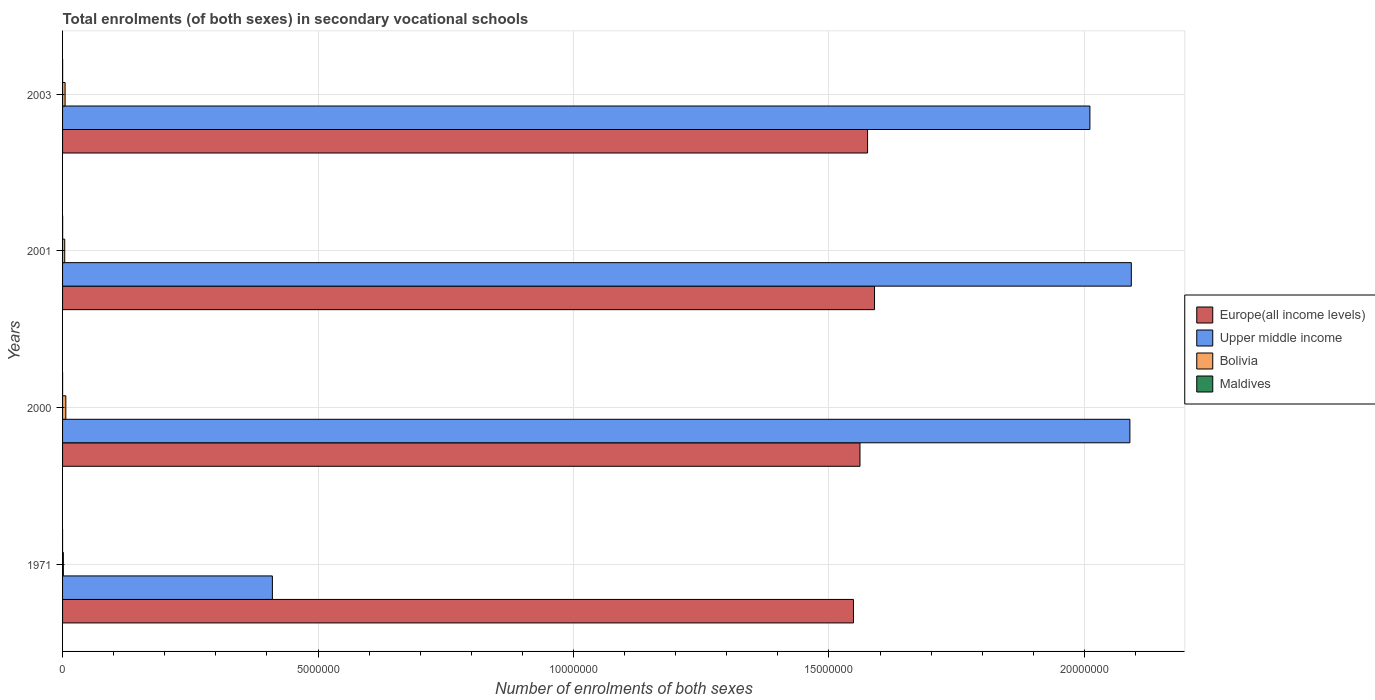How many different coloured bars are there?
Offer a very short reply. 4. Are the number of bars on each tick of the Y-axis equal?
Provide a short and direct response. Yes. How many bars are there on the 2nd tick from the top?
Provide a succinct answer. 4. How many bars are there on the 1st tick from the bottom?
Offer a terse response. 4. What is the label of the 1st group of bars from the top?
Your response must be concise. 2003. What is the number of enrolments in secondary schools in Bolivia in 2000?
Give a very brief answer. 6.38e+04. Across all years, what is the maximum number of enrolments in secondary schools in Upper middle income?
Your answer should be very brief. 2.09e+07. Across all years, what is the minimum number of enrolments in secondary schools in Europe(all income levels)?
Offer a very short reply. 1.55e+07. In which year was the number of enrolments in secondary schools in Maldives minimum?
Make the answer very short. 1971. What is the total number of enrolments in secondary schools in Maldives in the graph?
Your answer should be compact. 3080. What is the difference between the number of enrolments in secondary schools in Bolivia in 1971 and that in 2003?
Provide a short and direct response. -3.39e+04. What is the difference between the number of enrolments in secondary schools in Europe(all income levels) in 1971 and the number of enrolments in secondary schools in Maldives in 2003?
Your answer should be compact. 1.55e+07. What is the average number of enrolments in secondary schools in Europe(all income levels) per year?
Give a very brief answer. 1.57e+07. In the year 2000, what is the difference between the number of enrolments in secondary schools in Maldives and number of enrolments in secondary schools in Europe(all income levels)?
Your answer should be very brief. -1.56e+07. What is the ratio of the number of enrolments in secondary schools in Europe(all income levels) in 2001 to that in 2003?
Provide a short and direct response. 1.01. Is the number of enrolments in secondary schools in Maldives in 1971 less than that in 2000?
Your answer should be very brief. Yes. What is the difference between the highest and the second highest number of enrolments in secondary schools in Bolivia?
Provide a short and direct response. 1.42e+04. What is the difference between the highest and the lowest number of enrolments in secondary schools in Bolivia?
Provide a short and direct response. 4.81e+04. What does the 3rd bar from the top in 1971 represents?
Your answer should be compact. Upper middle income. What does the 1st bar from the bottom in 2001 represents?
Your response must be concise. Europe(all income levels). Is it the case that in every year, the sum of the number of enrolments in secondary schools in Maldives and number of enrolments in secondary schools in Bolivia is greater than the number of enrolments in secondary schools in Europe(all income levels)?
Provide a succinct answer. No. How many bars are there?
Your answer should be very brief. 16. What is the difference between two consecutive major ticks on the X-axis?
Offer a very short reply. 5.00e+06. Does the graph contain grids?
Offer a terse response. Yes. Where does the legend appear in the graph?
Your answer should be very brief. Center right. How many legend labels are there?
Offer a terse response. 4. What is the title of the graph?
Your answer should be compact. Total enrolments (of both sexes) in secondary vocational schools. Does "Mauritius" appear as one of the legend labels in the graph?
Your response must be concise. No. What is the label or title of the X-axis?
Give a very brief answer. Number of enrolments of both sexes. What is the Number of enrolments of both sexes in Europe(all income levels) in 1971?
Offer a very short reply. 1.55e+07. What is the Number of enrolments of both sexes of Upper middle income in 1971?
Your answer should be compact. 4.11e+06. What is the Number of enrolments of both sexes in Bolivia in 1971?
Provide a short and direct response. 1.57e+04. What is the Number of enrolments of both sexes in Maldives in 1971?
Offer a very short reply. 11. What is the Number of enrolments of both sexes in Europe(all income levels) in 2000?
Your answer should be very brief. 1.56e+07. What is the Number of enrolments of both sexes of Upper middle income in 2000?
Keep it short and to the point. 2.09e+07. What is the Number of enrolments of both sexes of Bolivia in 2000?
Your answer should be very brief. 6.38e+04. What is the Number of enrolments of both sexes of Maldives in 2000?
Provide a succinct answer. 457. What is the Number of enrolments of both sexes of Europe(all income levels) in 2001?
Your answer should be compact. 1.59e+07. What is the Number of enrolments of both sexes in Upper middle income in 2001?
Provide a succinct answer. 2.09e+07. What is the Number of enrolments of both sexes in Bolivia in 2001?
Ensure brevity in your answer.  4.20e+04. What is the Number of enrolments of both sexes in Maldives in 2001?
Make the answer very short. 1521. What is the Number of enrolments of both sexes in Europe(all income levels) in 2003?
Your response must be concise. 1.58e+07. What is the Number of enrolments of both sexes of Upper middle income in 2003?
Your response must be concise. 2.01e+07. What is the Number of enrolments of both sexes of Bolivia in 2003?
Provide a short and direct response. 4.96e+04. What is the Number of enrolments of both sexes of Maldives in 2003?
Your answer should be compact. 1091. Across all years, what is the maximum Number of enrolments of both sexes of Europe(all income levels)?
Your answer should be compact. 1.59e+07. Across all years, what is the maximum Number of enrolments of both sexes of Upper middle income?
Provide a short and direct response. 2.09e+07. Across all years, what is the maximum Number of enrolments of both sexes in Bolivia?
Your answer should be compact. 6.38e+04. Across all years, what is the maximum Number of enrolments of both sexes in Maldives?
Make the answer very short. 1521. Across all years, what is the minimum Number of enrolments of both sexes in Europe(all income levels)?
Offer a terse response. 1.55e+07. Across all years, what is the minimum Number of enrolments of both sexes in Upper middle income?
Give a very brief answer. 4.11e+06. Across all years, what is the minimum Number of enrolments of both sexes in Bolivia?
Provide a short and direct response. 1.57e+04. What is the total Number of enrolments of both sexes of Europe(all income levels) in the graph?
Your response must be concise. 6.27e+07. What is the total Number of enrolments of both sexes in Upper middle income in the graph?
Provide a succinct answer. 6.60e+07. What is the total Number of enrolments of both sexes of Bolivia in the graph?
Make the answer very short. 1.71e+05. What is the total Number of enrolments of both sexes in Maldives in the graph?
Your answer should be very brief. 3080. What is the difference between the Number of enrolments of both sexes of Europe(all income levels) in 1971 and that in 2000?
Provide a succinct answer. -1.27e+05. What is the difference between the Number of enrolments of both sexes in Upper middle income in 1971 and that in 2000?
Offer a very short reply. -1.68e+07. What is the difference between the Number of enrolments of both sexes of Bolivia in 1971 and that in 2000?
Make the answer very short. -4.81e+04. What is the difference between the Number of enrolments of both sexes of Maldives in 1971 and that in 2000?
Your response must be concise. -446. What is the difference between the Number of enrolments of both sexes of Europe(all income levels) in 1971 and that in 2001?
Offer a very short reply. -4.12e+05. What is the difference between the Number of enrolments of both sexes of Upper middle income in 1971 and that in 2001?
Provide a short and direct response. -1.68e+07. What is the difference between the Number of enrolments of both sexes in Bolivia in 1971 and that in 2001?
Your response must be concise. -2.63e+04. What is the difference between the Number of enrolments of both sexes of Maldives in 1971 and that in 2001?
Keep it short and to the point. -1510. What is the difference between the Number of enrolments of both sexes of Europe(all income levels) in 1971 and that in 2003?
Keep it short and to the point. -2.76e+05. What is the difference between the Number of enrolments of both sexes in Upper middle income in 1971 and that in 2003?
Keep it short and to the point. -1.60e+07. What is the difference between the Number of enrolments of both sexes of Bolivia in 1971 and that in 2003?
Give a very brief answer. -3.39e+04. What is the difference between the Number of enrolments of both sexes of Maldives in 1971 and that in 2003?
Ensure brevity in your answer.  -1080. What is the difference between the Number of enrolments of both sexes of Europe(all income levels) in 2000 and that in 2001?
Give a very brief answer. -2.85e+05. What is the difference between the Number of enrolments of both sexes in Upper middle income in 2000 and that in 2001?
Your answer should be compact. -2.76e+04. What is the difference between the Number of enrolments of both sexes in Bolivia in 2000 and that in 2001?
Your response must be concise. 2.18e+04. What is the difference between the Number of enrolments of both sexes of Maldives in 2000 and that in 2001?
Your response must be concise. -1064. What is the difference between the Number of enrolments of both sexes in Europe(all income levels) in 2000 and that in 2003?
Give a very brief answer. -1.48e+05. What is the difference between the Number of enrolments of both sexes of Upper middle income in 2000 and that in 2003?
Provide a succinct answer. 7.83e+05. What is the difference between the Number of enrolments of both sexes in Bolivia in 2000 and that in 2003?
Offer a very short reply. 1.42e+04. What is the difference between the Number of enrolments of both sexes of Maldives in 2000 and that in 2003?
Provide a short and direct response. -634. What is the difference between the Number of enrolments of both sexes in Europe(all income levels) in 2001 and that in 2003?
Offer a terse response. 1.36e+05. What is the difference between the Number of enrolments of both sexes in Upper middle income in 2001 and that in 2003?
Ensure brevity in your answer.  8.10e+05. What is the difference between the Number of enrolments of both sexes of Bolivia in 2001 and that in 2003?
Provide a succinct answer. -7616. What is the difference between the Number of enrolments of both sexes of Maldives in 2001 and that in 2003?
Your answer should be very brief. 430. What is the difference between the Number of enrolments of both sexes in Europe(all income levels) in 1971 and the Number of enrolments of both sexes in Upper middle income in 2000?
Offer a terse response. -5.41e+06. What is the difference between the Number of enrolments of both sexes of Europe(all income levels) in 1971 and the Number of enrolments of both sexes of Bolivia in 2000?
Your answer should be compact. 1.54e+07. What is the difference between the Number of enrolments of both sexes of Europe(all income levels) in 1971 and the Number of enrolments of both sexes of Maldives in 2000?
Offer a terse response. 1.55e+07. What is the difference between the Number of enrolments of both sexes of Upper middle income in 1971 and the Number of enrolments of both sexes of Bolivia in 2000?
Ensure brevity in your answer.  4.04e+06. What is the difference between the Number of enrolments of both sexes in Upper middle income in 1971 and the Number of enrolments of both sexes in Maldives in 2000?
Keep it short and to the point. 4.11e+06. What is the difference between the Number of enrolments of both sexes in Bolivia in 1971 and the Number of enrolments of both sexes in Maldives in 2000?
Keep it short and to the point. 1.52e+04. What is the difference between the Number of enrolments of both sexes in Europe(all income levels) in 1971 and the Number of enrolments of both sexes in Upper middle income in 2001?
Provide a succinct answer. -5.44e+06. What is the difference between the Number of enrolments of both sexes in Europe(all income levels) in 1971 and the Number of enrolments of both sexes in Bolivia in 2001?
Your response must be concise. 1.54e+07. What is the difference between the Number of enrolments of both sexes of Europe(all income levels) in 1971 and the Number of enrolments of both sexes of Maldives in 2001?
Offer a very short reply. 1.55e+07. What is the difference between the Number of enrolments of both sexes of Upper middle income in 1971 and the Number of enrolments of both sexes of Bolivia in 2001?
Keep it short and to the point. 4.06e+06. What is the difference between the Number of enrolments of both sexes of Upper middle income in 1971 and the Number of enrolments of both sexes of Maldives in 2001?
Your response must be concise. 4.11e+06. What is the difference between the Number of enrolments of both sexes in Bolivia in 1971 and the Number of enrolments of both sexes in Maldives in 2001?
Ensure brevity in your answer.  1.42e+04. What is the difference between the Number of enrolments of both sexes in Europe(all income levels) in 1971 and the Number of enrolments of both sexes in Upper middle income in 2003?
Your response must be concise. -4.63e+06. What is the difference between the Number of enrolments of both sexes of Europe(all income levels) in 1971 and the Number of enrolments of both sexes of Bolivia in 2003?
Give a very brief answer. 1.54e+07. What is the difference between the Number of enrolments of both sexes of Europe(all income levels) in 1971 and the Number of enrolments of both sexes of Maldives in 2003?
Your answer should be very brief. 1.55e+07. What is the difference between the Number of enrolments of both sexes in Upper middle income in 1971 and the Number of enrolments of both sexes in Bolivia in 2003?
Your answer should be very brief. 4.06e+06. What is the difference between the Number of enrolments of both sexes of Upper middle income in 1971 and the Number of enrolments of both sexes of Maldives in 2003?
Your answer should be very brief. 4.11e+06. What is the difference between the Number of enrolments of both sexes of Bolivia in 1971 and the Number of enrolments of both sexes of Maldives in 2003?
Your response must be concise. 1.46e+04. What is the difference between the Number of enrolments of both sexes of Europe(all income levels) in 2000 and the Number of enrolments of both sexes of Upper middle income in 2001?
Provide a short and direct response. -5.31e+06. What is the difference between the Number of enrolments of both sexes of Europe(all income levels) in 2000 and the Number of enrolments of both sexes of Bolivia in 2001?
Ensure brevity in your answer.  1.56e+07. What is the difference between the Number of enrolments of both sexes in Europe(all income levels) in 2000 and the Number of enrolments of both sexes in Maldives in 2001?
Make the answer very short. 1.56e+07. What is the difference between the Number of enrolments of both sexes in Upper middle income in 2000 and the Number of enrolments of both sexes in Bolivia in 2001?
Keep it short and to the point. 2.08e+07. What is the difference between the Number of enrolments of both sexes in Upper middle income in 2000 and the Number of enrolments of both sexes in Maldives in 2001?
Offer a terse response. 2.09e+07. What is the difference between the Number of enrolments of both sexes of Bolivia in 2000 and the Number of enrolments of both sexes of Maldives in 2001?
Keep it short and to the point. 6.22e+04. What is the difference between the Number of enrolments of both sexes in Europe(all income levels) in 2000 and the Number of enrolments of both sexes in Upper middle income in 2003?
Your answer should be very brief. -4.50e+06. What is the difference between the Number of enrolments of both sexes in Europe(all income levels) in 2000 and the Number of enrolments of both sexes in Bolivia in 2003?
Provide a succinct answer. 1.56e+07. What is the difference between the Number of enrolments of both sexes of Europe(all income levels) in 2000 and the Number of enrolments of both sexes of Maldives in 2003?
Give a very brief answer. 1.56e+07. What is the difference between the Number of enrolments of both sexes in Upper middle income in 2000 and the Number of enrolments of both sexes in Bolivia in 2003?
Keep it short and to the point. 2.08e+07. What is the difference between the Number of enrolments of both sexes of Upper middle income in 2000 and the Number of enrolments of both sexes of Maldives in 2003?
Your response must be concise. 2.09e+07. What is the difference between the Number of enrolments of both sexes of Bolivia in 2000 and the Number of enrolments of both sexes of Maldives in 2003?
Your response must be concise. 6.27e+04. What is the difference between the Number of enrolments of both sexes in Europe(all income levels) in 2001 and the Number of enrolments of both sexes in Upper middle income in 2003?
Offer a very short reply. -4.22e+06. What is the difference between the Number of enrolments of both sexes of Europe(all income levels) in 2001 and the Number of enrolments of both sexes of Bolivia in 2003?
Your answer should be very brief. 1.58e+07. What is the difference between the Number of enrolments of both sexes of Europe(all income levels) in 2001 and the Number of enrolments of both sexes of Maldives in 2003?
Your answer should be compact. 1.59e+07. What is the difference between the Number of enrolments of both sexes of Upper middle income in 2001 and the Number of enrolments of both sexes of Bolivia in 2003?
Provide a succinct answer. 2.09e+07. What is the difference between the Number of enrolments of both sexes of Upper middle income in 2001 and the Number of enrolments of both sexes of Maldives in 2003?
Give a very brief answer. 2.09e+07. What is the difference between the Number of enrolments of both sexes of Bolivia in 2001 and the Number of enrolments of both sexes of Maldives in 2003?
Offer a terse response. 4.09e+04. What is the average Number of enrolments of both sexes in Europe(all income levels) per year?
Offer a very short reply. 1.57e+07. What is the average Number of enrolments of both sexes in Upper middle income per year?
Provide a succinct answer. 1.65e+07. What is the average Number of enrolments of both sexes of Bolivia per year?
Your response must be concise. 4.28e+04. What is the average Number of enrolments of both sexes of Maldives per year?
Give a very brief answer. 770. In the year 1971, what is the difference between the Number of enrolments of both sexes in Europe(all income levels) and Number of enrolments of both sexes in Upper middle income?
Your response must be concise. 1.14e+07. In the year 1971, what is the difference between the Number of enrolments of both sexes in Europe(all income levels) and Number of enrolments of both sexes in Bolivia?
Your answer should be compact. 1.55e+07. In the year 1971, what is the difference between the Number of enrolments of both sexes in Europe(all income levels) and Number of enrolments of both sexes in Maldives?
Offer a very short reply. 1.55e+07. In the year 1971, what is the difference between the Number of enrolments of both sexes of Upper middle income and Number of enrolments of both sexes of Bolivia?
Ensure brevity in your answer.  4.09e+06. In the year 1971, what is the difference between the Number of enrolments of both sexes in Upper middle income and Number of enrolments of both sexes in Maldives?
Ensure brevity in your answer.  4.11e+06. In the year 1971, what is the difference between the Number of enrolments of both sexes of Bolivia and Number of enrolments of both sexes of Maldives?
Ensure brevity in your answer.  1.57e+04. In the year 2000, what is the difference between the Number of enrolments of both sexes of Europe(all income levels) and Number of enrolments of both sexes of Upper middle income?
Your answer should be very brief. -5.28e+06. In the year 2000, what is the difference between the Number of enrolments of both sexes in Europe(all income levels) and Number of enrolments of both sexes in Bolivia?
Offer a terse response. 1.55e+07. In the year 2000, what is the difference between the Number of enrolments of both sexes in Europe(all income levels) and Number of enrolments of both sexes in Maldives?
Offer a very short reply. 1.56e+07. In the year 2000, what is the difference between the Number of enrolments of both sexes in Upper middle income and Number of enrolments of both sexes in Bolivia?
Your answer should be very brief. 2.08e+07. In the year 2000, what is the difference between the Number of enrolments of both sexes of Upper middle income and Number of enrolments of both sexes of Maldives?
Provide a short and direct response. 2.09e+07. In the year 2000, what is the difference between the Number of enrolments of both sexes of Bolivia and Number of enrolments of both sexes of Maldives?
Ensure brevity in your answer.  6.33e+04. In the year 2001, what is the difference between the Number of enrolments of both sexes in Europe(all income levels) and Number of enrolments of both sexes in Upper middle income?
Provide a succinct answer. -5.03e+06. In the year 2001, what is the difference between the Number of enrolments of both sexes in Europe(all income levels) and Number of enrolments of both sexes in Bolivia?
Offer a terse response. 1.59e+07. In the year 2001, what is the difference between the Number of enrolments of both sexes of Europe(all income levels) and Number of enrolments of both sexes of Maldives?
Your response must be concise. 1.59e+07. In the year 2001, what is the difference between the Number of enrolments of both sexes in Upper middle income and Number of enrolments of both sexes in Bolivia?
Give a very brief answer. 2.09e+07. In the year 2001, what is the difference between the Number of enrolments of both sexes of Upper middle income and Number of enrolments of both sexes of Maldives?
Give a very brief answer. 2.09e+07. In the year 2001, what is the difference between the Number of enrolments of both sexes in Bolivia and Number of enrolments of both sexes in Maldives?
Your answer should be very brief. 4.05e+04. In the year 2003, what is the difference between the Number of enrolments of both sexes in Europe(all income levels) and Number of enrolments of both sexes in Upper middle income?
Give a very brief answer. -4.35e+06. In the year 2003, what is the difference between the Number of enrolments of both sexes in Europe(all income levels) and Number of enrolments of both sexes in Bolivia?
Provide a short and direct response. 1.57e+07. In the year 2003, what is the difference between the Number of enrolments of both sexes of Europe(all income levels) and Number of enrolments of both sexes of Maldives?
Give a very brief answer. 1.58e+07. In the year 2003, what is the difference between the Number of enrolments of both sexes in Upper middle income and Number of enrolments of both sexes in Bolivia?
Provide a succinct answer. 2.01e+07. In the year 2003, what is the difference between the Number of enrolments of both sexes of Upper middle income and Number of enrolments of both sexes of Maldives?
Keep it short and to the point. 2.01e+07. In the year 2003, what is the difference between the Number of enrolments of both sexes of Bolivia and Number of enrolments of both sexes of Maldives?
Your answer should be compact. 4.85e+04. What is the ratio of the Number of enrolments of both sexes of Europe(all income levels) in 1971 to that in 2000?
Provide a succinct answer. 0.99. What is the ratio of the Number of enrolments of both sexes in Upper middle income in 1971 to that in 2000?
Give a very brief answer. 0.2. What is the ratio of the Number of enrolments of both sexes of Bolivia in 1971 to that in 2000?
Keep it short and to the point. 0.25. What is the ratio of the Number of enrolments of both sexes in Maldives in 1971 to that in 2000?
Your response must be concise. 0.02. What is the ratio of the Number of enrolments of both sexes in Europe(all income levels) in 1971 to that in 2001?
Make the answer very short. 0.97. What is the ratio of the Number of enrolments of both sexes of Upper middle income in 1971 to that in 2001?
Your answer should be compact. 0.2. What is the ratio of the Number of enrolments of both sexes of Bolivia in 1971 to that in 2001?
Your answer should be compact. 0.37. What is the ratio of the Number of enrolments of both sexes of Maldives in 1971 to that in 2001?
Make the answer very short. 0.01. What is the ratio of the Number of enrolments of both sexes of Europe(all income levels) in 1971 to that in 2003?
Your answer should be compact. 0.98. What is the ratio of the Number of enrolments of both sexes in Upper middle income in 1971 to that in 2003?
Make the answer very short. 0.2. What is the ratio of the Number of enrolments of both sexes of Bolivia in 1971 to that in 2003?
Ensure brevity in your answer.  0.32. What is the ratio of the Number of enrolments of both sexes in Maldives in 1971 to that in 2003?
Offer a terse response. 0.01. What is the ratio of the Number of enrolments of both sexes of Europe(all income levels) in 2000 to that in 2001?
Provide a succinct answer. 0.98. What is the ratio of the Number of enrolments of both sexes of Bolivia in 2000 to that in 2001?
Provide a short and direct response. 1.52. What is the ratio of the Number of enrolments of both sexes of Maldives in 2000 to that in 2001?
Offer a very short reply. 0.3. What is the ratio of the Number of enrolments of both sexes in Europe(all income levels) in 2000 to that in 2003?
Your answer should be very brief. 0.99. What is the ratio of the Number of enrolments of both sexes of Upper middle income in 2000 to that in 2003?
Provide a succinct answer. 1.04. What is the ratio of the Number of enrolments of both sexes in Bolivia in 2000 to that in 2003?
Ensure brevity in your answer.  1.29. What is the ratio of the Number of enrolments of both sexes in Maldives in 2000 to that in 2003?
Your response must be concise. 0.42. What is the ratio of the Number of enrolments of both sexes in Europe(all income levels) in 2001 to that in 2003?
Your answer should be very brief. 1.01. What is the ratio of the Number of enrolments of both sexes in Upper middle income in 2001 to that in 2003?
Provide a short and direct response. 1.04. What is the ratio of the Number of enrolments of both sexes of Bolivia in 2001 to that in 2003?
Your response must be concise. 0.85. What is the ratio of the Number of enrolments of both sexes of Maldives in 2001 to that in 2003?
Give a very brief answer. 1.39. What is the difference between the highest and the second highest Number of enrolments of both sexes of Europe(all income levels)?
Your response must be concise. 1.36e+05. What is the difference between the highest and the second highest Number of enrolments of both sexes in Upper middle income?
Provide a succinct answer. 2.76e+04. What is the difference between the highest and the second highest Number of enrolments of both sexes in Bolivia?
Provide a short and direct response. 1.42e+04. What is the difference between the highest and the second highest Number of enrolments of both sexes in Maldives?
Ensure brevity in your answer.  430. What is the difference between the highest and the lowest Number of enrolments of both sexes of Europe(all income levels)?
Your answer should be compact. 4.12e+05. What is the difference between the highest and the lowest Number of enrolments of both sexes in Upper middle income?
Offer a very short reply. 1.68e+07. What is the difference between the highest and the lowest Number of enrolments of both sexes in Bolivia?
Give a very brief answer. 4.81e+04. What is the difference between the highest and the lowest Number of enrolments of both sexes of Maldives?
Offer a very short reply. 1510. 